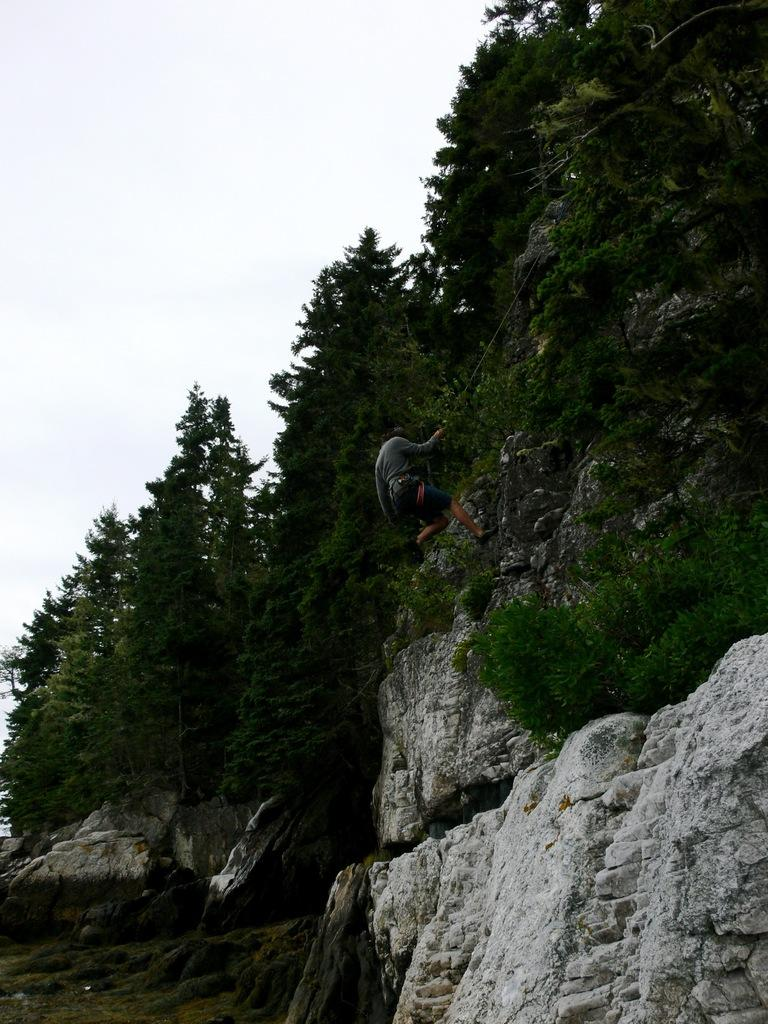What is the man in the image doing? The man is climbing in the image. Where is the man located in the image? The man is in the center of the image. What type of vegetation is present in the image? There are trees in the image. What is the ground covered with in the image? The ground is covered with grass in the image. What is the condition of the sky in the image? The sky is cloudy in the image. How many pizzas are being delivered in the image? There are no pizzas or delivery in the image; it features a man climbing with trees, grass, and a cloudy sky. What message is written on the sign in the image? There is no sign present in the image. 